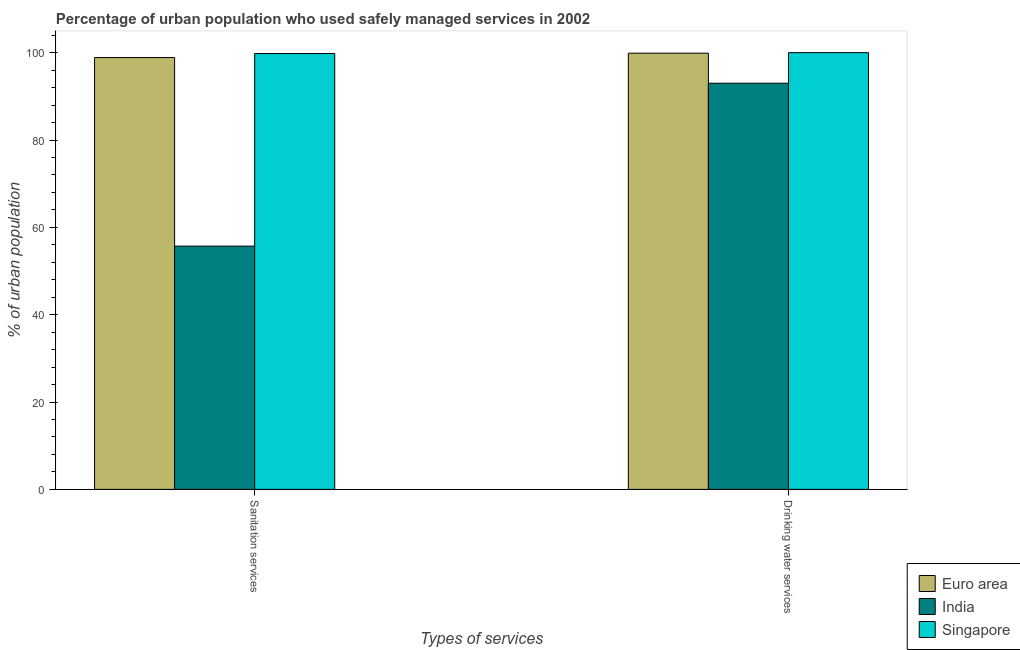Are the number of bars per tick equal to the number of legend labels?
Your answer should be very brief. Yes. What is the label of the 2nd group of bars from the left?
Provide a succinct answer. Drinking water services. What is the percentage of urban population who used sanitation services in Euro area?
Keep it short and to the point. 98.88. Across all countries, what is the maximum percentage of urban population who used drinking water services?
Your answer should be compact. 100. Across all countries, what is the minimum percentage of urban population who used sanitation services?
Provide a short and direct response. 55.7. In which country was the percentage of urban population who used sanitation services maximum?
Provide a succinct answer. Singapore. What is the total percentage of urban population who used sanitation services in the graph?
Ensure brevity in your answer.  254.38. What is the difference between the percentage of urban population who used sanitation services in India and that in Singapore?
Offer a terse response. -44.1. What is the difference between the percentage of urban population who used sanitation services in Euro area and the percentage of urban population who used drinking water services in Singapore?
Ensure brevity in your answer.  -1.12. What is the average percentage of urban population who used sanitation services per country?
Your answer should be compact. 84.79. What is the difference between the percentage of urban population who used drinking water services and percentage of urban population who used sanitation services in India?
Offer a very short reply. 37.3. What is the ratio of the percentage of urban population who used sanitation services in India to that in Singapore?
Your answer should be compact. 0.56. Is the percentage of urban population who used drinking water services in Singapore less than that in India?
Your answer should be compact. No. In how many countries, is the percentage of urban population who used drinking water services greater than the average percentage of urban population who used drinking water services taken over all countries?
Provide a succinct answer. 2. How many countries are there in the graph?
Provide a short and direct response. 3. Does the graph contain any zero values?
Give a very brief answer. No. Does the graph contain grids?
Provide a succinct answer. No. What is the title of the graph?
Offer a terse response. Percentage of urban population who used safely managed services in 2002. Does "India" appear as one of the legend labels in the graph?
Give a very brief answer. Yes. What is the label or title of the X-axis?
Provide a short and direct response. Types of services. What is the label or title of the Y-axis?
Your response must be concise. % of urban population. What is the % of urban population of Euro area in Sanitation services?
Provide a succinct answer. 98.88. What is the % of urban population in India in Sanitation services?
Make the answer very short. 55.7. What is the % of urban population of Singapore in Sanitation services?
Keep it short and to the point. 99.8. What is the % of urban population of Euro area in Drinking water services?
Offer a terse response. 99.88. What is the % of urban population of India in Drinking water services?
Offer a terse response. 93. What is the % of urban population in Singapore in Drinking water services?
Ensure brevity in your answer.  100. Across all Types of services, what is the maximum % of urban population in Euro area?
Provide a succinct answer. 99.88. Across all Types of services, what is the maximum % of urban population of India?
Offer a very short reply. 93. Across all Types of services, what is the minimum % of urban population of Euro area?
Provide a succinct answer. 98.88. Across all Types of services, what is the minimum % of urban population of India?
Your response must be concise. 55.7. Across all Types of services, what is the minimum % of urban population of Singapore?
Make the answer very short. 99.8. What is the total % of urban population of Euro area in the graph?
Offer a very short reply. 198.76. What is the total % of urban population in India in the graph?
Make the answer very short. 148.7. What is the total % of urban population in Singapore in the graph?
Give a very brief answer. 199.8. What is the difference between the % of urban population in Euro area in Sanitation services and that in Drinking water services?
Offer a terse response. -1. What is the difference between the % of urban population in India in Sanitation services and that in Drinking water services?
Your answer should be very brief. -37.3. What is the difference between the % of urban population in Euro area in Sanitation services and the % of urban population in India in Drinking water services?
Make the answer very short. 5.88. What is the difference between the % of urban population of Euro area in Sanitation services and the % of urban population of Singapore in Drinking water services?
Keep it short and to the point. -1.12. What is the difference between the % of urban population of India in Sanitation services and the % of urban population of Singapore in Drinking water services?
Provide a succinct answer. -44.3. What is the average % of urban population of Euro area per Types of services?
Offer a terse response. 99.38. What is the average % of urban population of India per Types of services?
Provide a short and direct response. 74.35. What is the average % of urban population of Singapore per Types of services?
Make the answer very short. 99.9. What is the difference between the % of urban population of Euro area and % of urban population of India in Sanitation services?
Ensure brevity in your answer.  43.18. What is the difference between the % of urban population in Euro area and % of urban population in Singapore in Sanitation services?
Give a very brief answer. -0.92. What is the difference between the % of urban population of India and % of urban population of Singapore in Sanitation services?
Offer a terse response. -44.1. What is the difference between the % of urban population in Euro area and % of urban population in India in Drinking water services?
Make the answer very short. 6.88. What is the difference between the % of urban population of Euro area and % of urban population of Singapore in Drinking water services?
Provide a succinct answer. -0.12. What is the ratio of the % of urban population of India in Sanitation services to that in Drinking water services?
Provide a short and direct response. 0.6. What is the difference between the highest and the second highest % of urban population of Euro area?
Keep it short and to the point. 1. What is the difference between the highest and the second highest % of urban population of India?
Provide a succinct answer. 37.3. What is the difference between the highest and the second highest % of urban population in Singapore?
Make the answer very short. 0.2. What is the difference between the highest and the lowest % of urban population of Euro area?
Provide a short and direct response. 1. What is the difference between the highest and the lowest % of urban population in India?
Your answer should be very brief. 37.3. What is the difference between the highest and the lowest % of urban population of Singapore?
Provide a succinct answer. 0.2. 